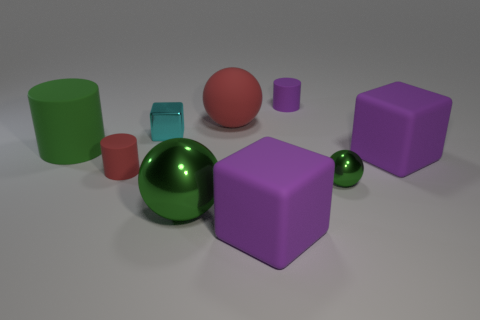Subtract all large red rubber spheres. How many spheres are left? 2 Subtract all brown blocks. How many green balls are left? 2 Subtract all cyan blocks. How many blocks are left? 2 Subtract all cylinders. How many objects are left? 6 Add 5 red balls. How many red balls exist? 6 Subtract 0 green blocks. How many objects are left? 9 Subtract 2 spheres. How many spheres are left? 1 Subtract all gray cylinders. Subtract all gray balls. How many cylinders are left? 3 Subtract all large rubber spheres. Subtract all small green spheres. How many objects are left? 7 Add 9 large green matte cylinders. How many large green matte cylinders are left? 10 